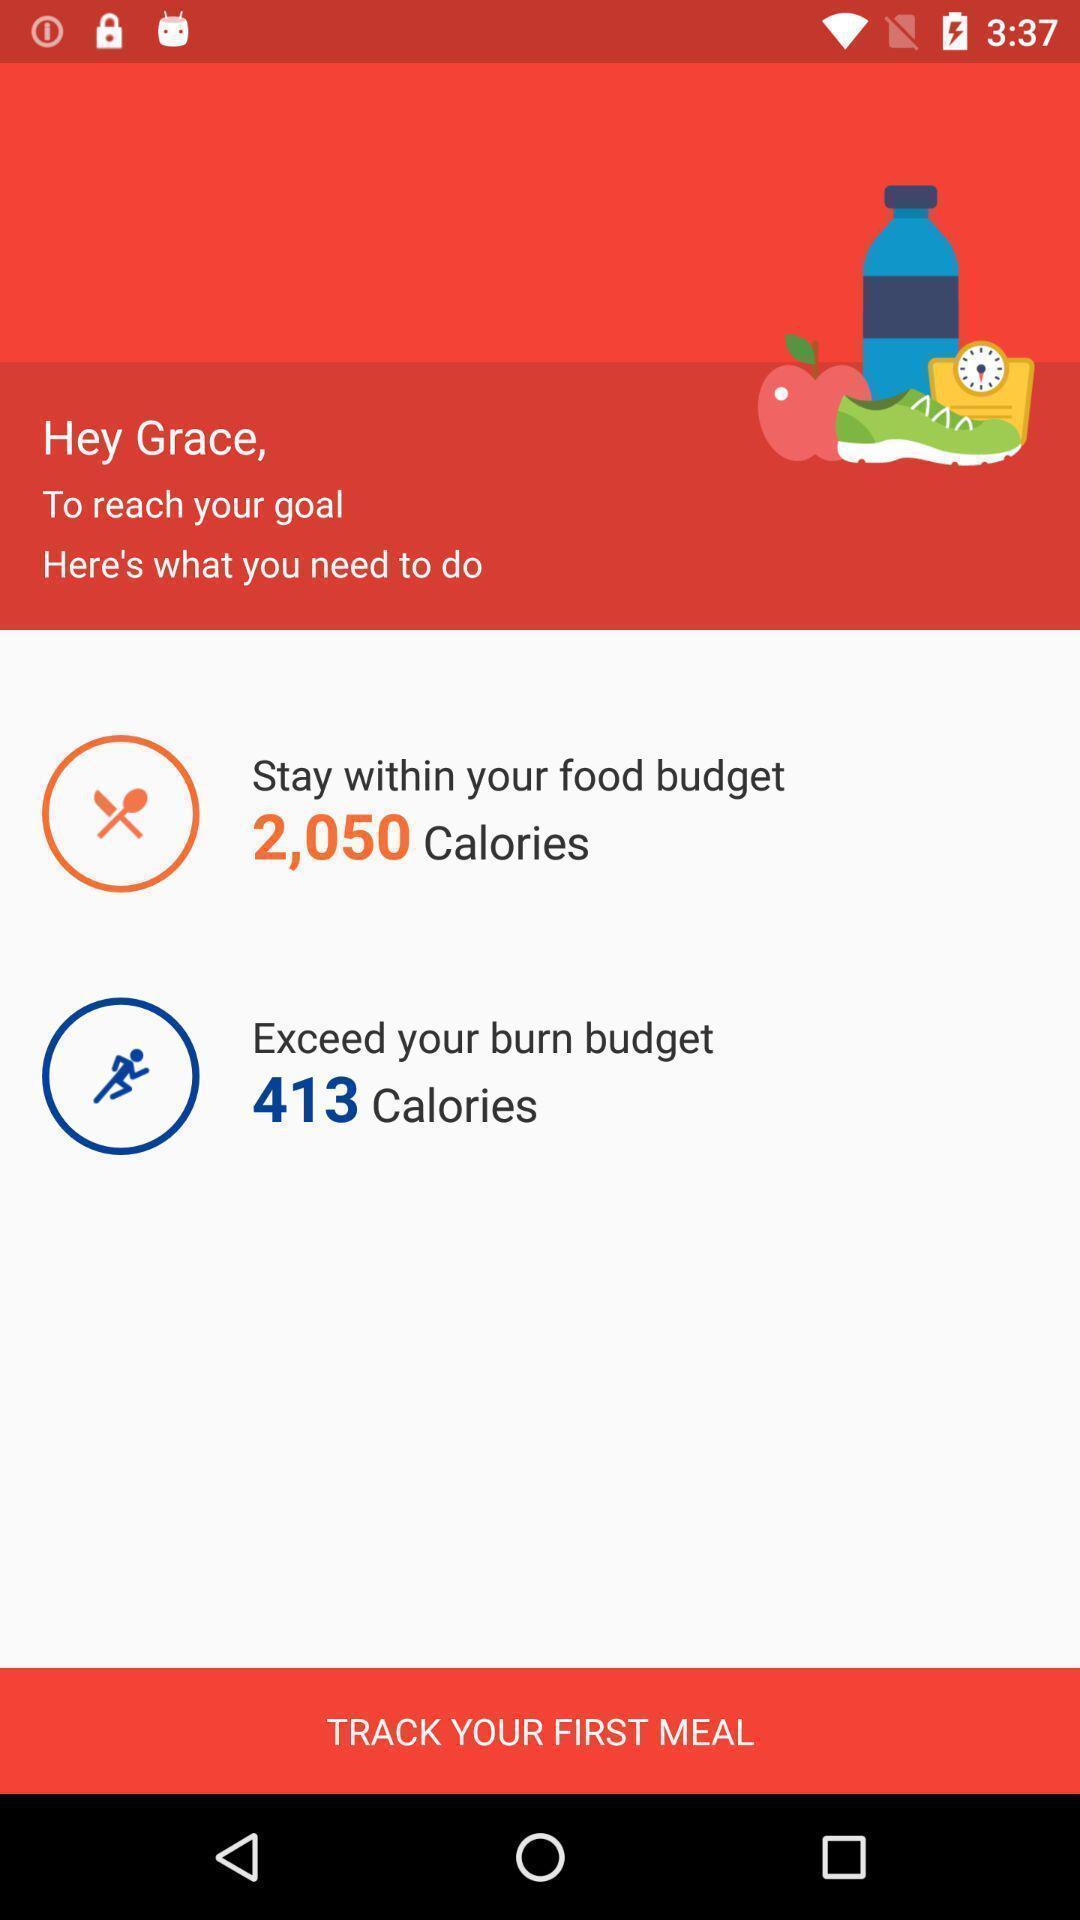Describe the visual elements of this screenshot. Page shows food budget and burn calories on health app. 